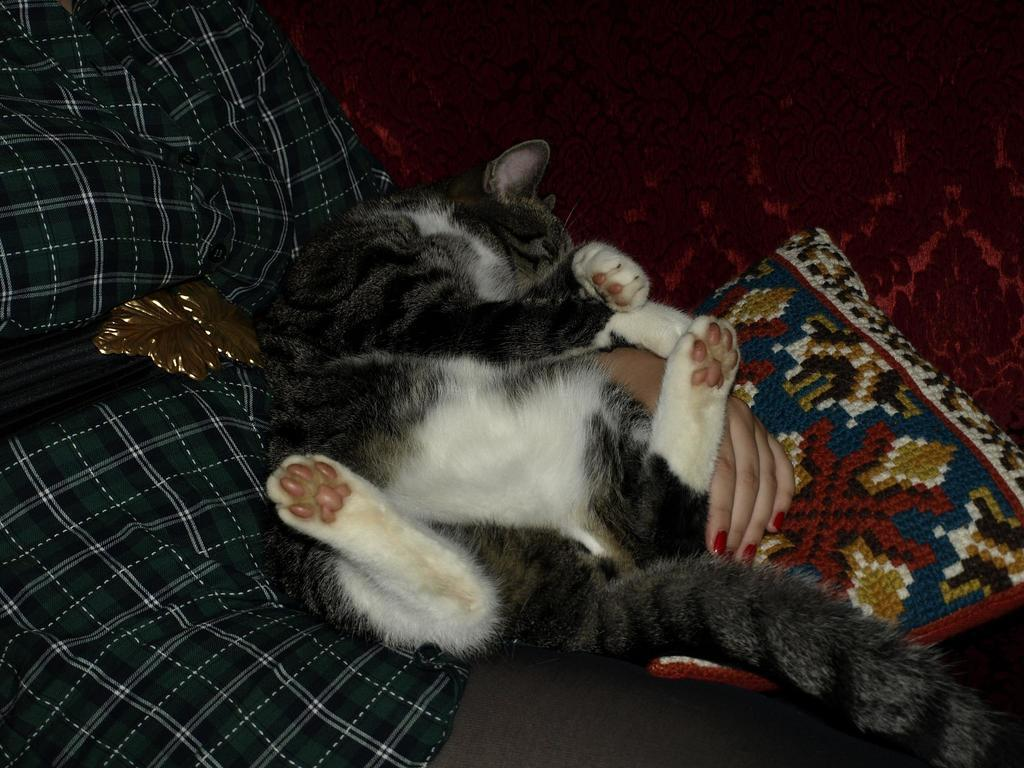What is the person in the image doing? The person is sitting on the sofa. What other living creature can be seen in the image? There is a cat in the image. What is placed on the sofa along with the person? There is a cushion placed on the sofa. What type of ice can be seen melting on the cat's fur in the image? There is no ice present in the image, and therefore no ice can be seen melting on the cat's fur. 